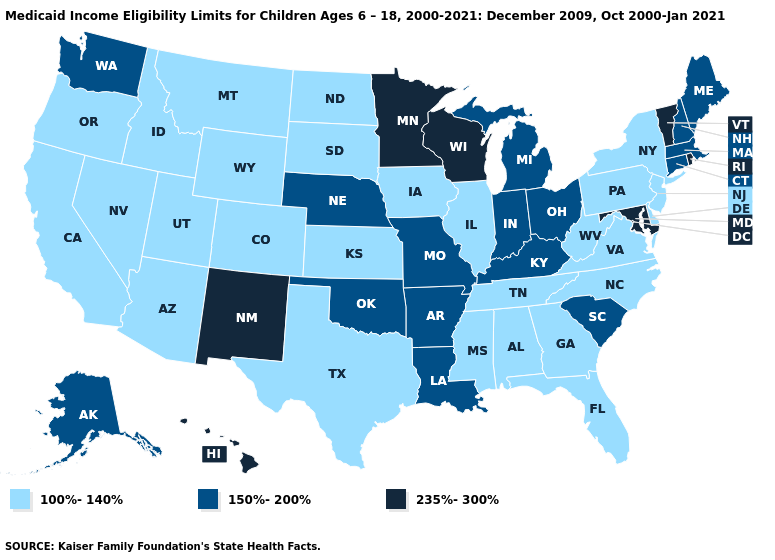Among the states that border Oklahoma , does Colorado have the lowest value?
Short answer required. Yes. What is the lowest value in the USA?
Concise answer only. 100%-140%. Is the legend a continuous bar?
Give a very brief answer. No. Name the states that have a value in the range 235%-300%?
Short answer required. Hawaii, Maryland, Minnesota, New Mexico, Rhode Island, Vermont, Wisconsin. Does the map have missing data?
Give a very brief answer. No. Name the states that have a value in the range 235%-300%?
Short answer required. Hawaii, Maryland, Minnesota, New Mexico, Rhode Island, Vermont, Wisconsin. Name the states that have a value in the range 100%-140%?
Quick response, please. Alabama, Arizona, California, Colorado, Delaware, Florida, Georgia, Idaho, Illinois, Iowa, Kansas, Mississippi, Montana, Nevada, New Jersey, New York, North Carolina, North Dakota, Oregon, Pennsylvania, South Dakota, Tennessee, Texas, Utah, Virginia, West Virginia, Wyoming. Among the states that border Oklahoma , which have the highest value?
Write a very short answer. New Mexico. Name the states that have a value in the range 100%-140%?
Keep it brief. Alabama, Arizona, California, Colorado, Delaware, Florida, Georgia, Idaho, Illinois, Iowa, Kansas, Mississippi, Montana, Nevada, New Jersey, New York, North Carolina, North Dakota, Oregon, Pennsylvania, South Dakota, Tennessee, Texas, Utah, Virginia, West Virginia, Wyoming. What is the value of Arkansas?
Write a very short answer. 150%-200%. What is the value of Arizona?
Quick response, please. 100%-140%. What is the value of Utah?
Keep it brief. 100%-140%. Name the states that have a value in the range 150%-200%?
Quick response, please. Alaska, Arkansas, Connecticut, Indiana, Kentucky, Louisiana, Maine, Massachusetts, Michigan, Missouri, Nebraska, New Hampshire, Ohio, Oklahoma, South Carolina, Washington. What is the value of New Mexico?
Short answer required. 235%-300%. 